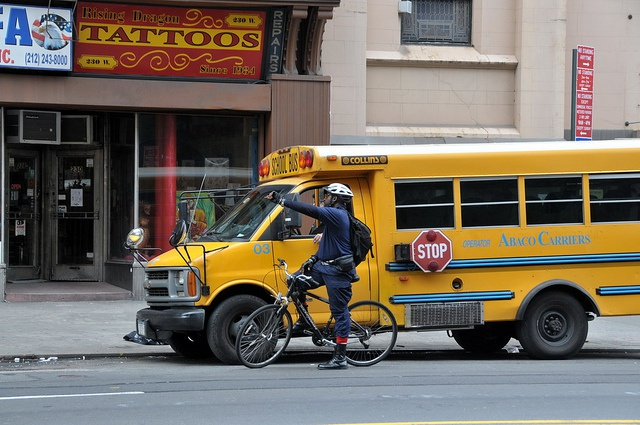Describe the objects in this image and their specific colors. I can see bus in black, orange, gray, and white tones, bicycle in black, gray, darkgray, and orange tones, people in black, navy, gray, and darkblue tones, stop sign in black, brown, lavender, and maroon tones, and backpack in black, gray, and orange tones in this image. 